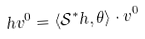<formula> <loc_0><loc_0><loc_500><loc_500>h v ^ { 0 } = \langle \mathcal { S } ^ { * } h , \theta \rangle \cdot v ^ { 0 }</formula> 